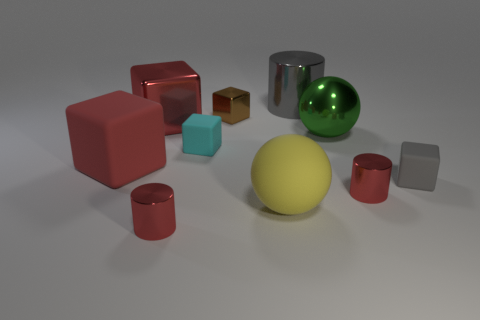What is the color of the small metal cylinder right of the big ball that is on the right side of the ball that is on the left side of the gray metal cylinder?
Your answer should be very brief. Red. Is the material of the large cylinder the same as the gray cube?
Offer a terse response. No. What number of objects are in front of the big red rubber object?
Keep it short and to the point. 4. What size is the cyan thing that is the same shape as the brown shiny object?
Offer a very short reply. Small. How many red objects are either large cylinders or small metal cylinders?
Keep it short and to the point. 2. There is a red shiny object that is to the right of the tiny cyan matte thing; what number of red objects are behind it?
Your answer should be very brief. 2. What number of other things are the same shape as the large gray metallic object?
Your response must be concise. 2. What material is the large thing that is the same color as the large rubber cube?
Keep it short and to the point. Metal. How many metal blocks are the same color as the big matte cube?
Ensure brevity in your answer.  1. The large block that is made of the same material as the large yellow object is what color?
Offer a terse response. Red. 